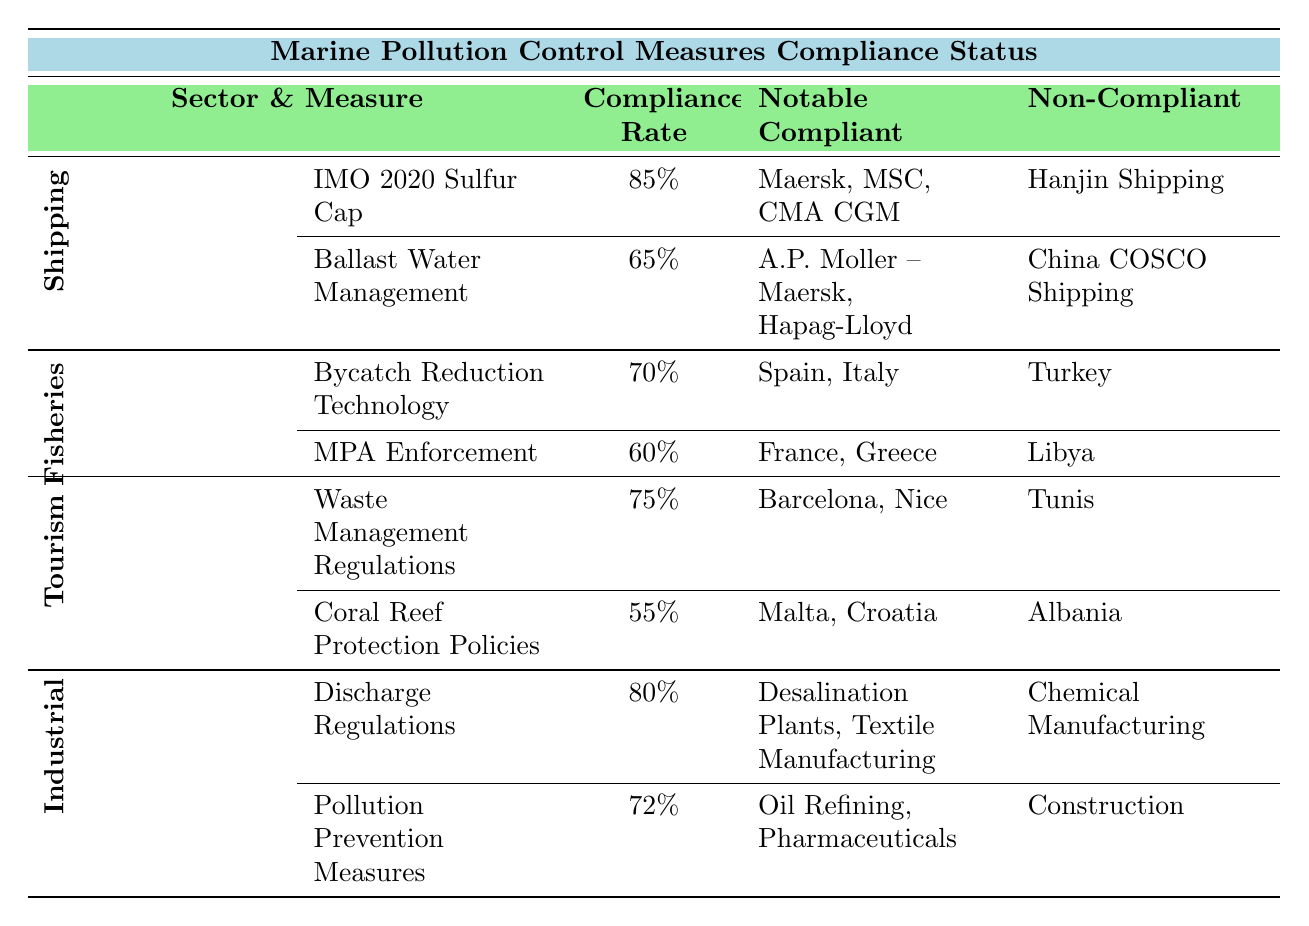What is the compliance rate for the IMO 2020 Sulfur Cap in the Shipping Industry? The table indicates the compliance rate for the IMO 2020 Sulfur Cap under the Shipping Industry section. It states that the compliance rate is 85%.
Answer: 85% Which sector has the highest compliance rate for pollution control measures? By comparing the compliance rates across all sectors presented in the table, we see that the Shipping Industry has the highest compliance rate for IMO 2020 Sulfur Cap at 85%, followed by the Industrial Sector's Discharge Regulations at 80%. Therefore, the Shipping Industry has the highest compliance rate overall.
Answer: Shipping Industry How many notable compliant countries are listed for the Bycatch Reduction Technology measure? The table shows that for the Bycatch Reduction Technology measure in the Fisheries Sector, the notable compliant countries listed are Spain and Italy, totaling two notable compliant countries.
Answer: 2 Is it true that the Tourism Sector has a compliance rate higher than the Fisheries Sector for any measure? The Tourism Sector has a compliance rate of 75% for Waste Management Regulations, which is higher than the Fisheries Sector's 70% for Bycatch Reduction Technology. Hence, it is true that the Tourism Sector has a higher compliance rate for at least one measure compared to the Fisheries Sector.
Answer: Yes What is the average compliance rate across all measures in the Industrial Sector? The compliance rates in the Industrial Sector are 80% for Discharge Regulations and 72% for Pollution Prevention Measures. To find the average, sum these rates (80 + 72 = 152) and divide by 2, resulting in an average of 76%.
Answer: 76% Which measure in the Tourism Sector has the lowest compliance rate and what is that rate? Looking at the measures in the Tourism Sector, Coral Reef Protection Policies has a compliance rate of 55%, which is lower than the Waste Management Regulations rate of 75%. Thus, Coral Reef Protection Policies has the lowest compliance rate of any measure in the Tourism Sector at 55%.
Answer: 55% Which notable companies are non-compliant with Ballast Water Management and what is their compliance rate? The table indicates that the non-compliant company for Ballast Water Management in the Shipping Industry is China COSCO Shipping, and the compliance rate for this measure is 65%.
Answer: China COSCO Shipping, 65% How many non-compliant destinations are reported for Coral Reef Protection Policies? The table notes that the non-compliant destination for Coral Reef Protection Policies in the Tourism Sector is Albania. Thus, there is one non-compliant destination reported for this measure.
Answer: 1 What is the compliance rate difference between Bycatch Reduction Technology and MPA Enforcement in the Fisheries Sector? The compliance rates for Bycatch Reduction Technology and MPA Enforcement are 70% and 60%, respectively. The difference is 70 - 60 = 10%, indicating that Bycatch Reduction Technology has a higher compliance rate by 10%.
Answer: 10% What notable industries are compliant under pollution prevention measures? The notable industries compliant under Pollution Prevention Measures in the Industrial Sector include Oil Refining and Pharmaceuticals as listed in the table.
Answer: Oil Refining, Pharmaceuticals 